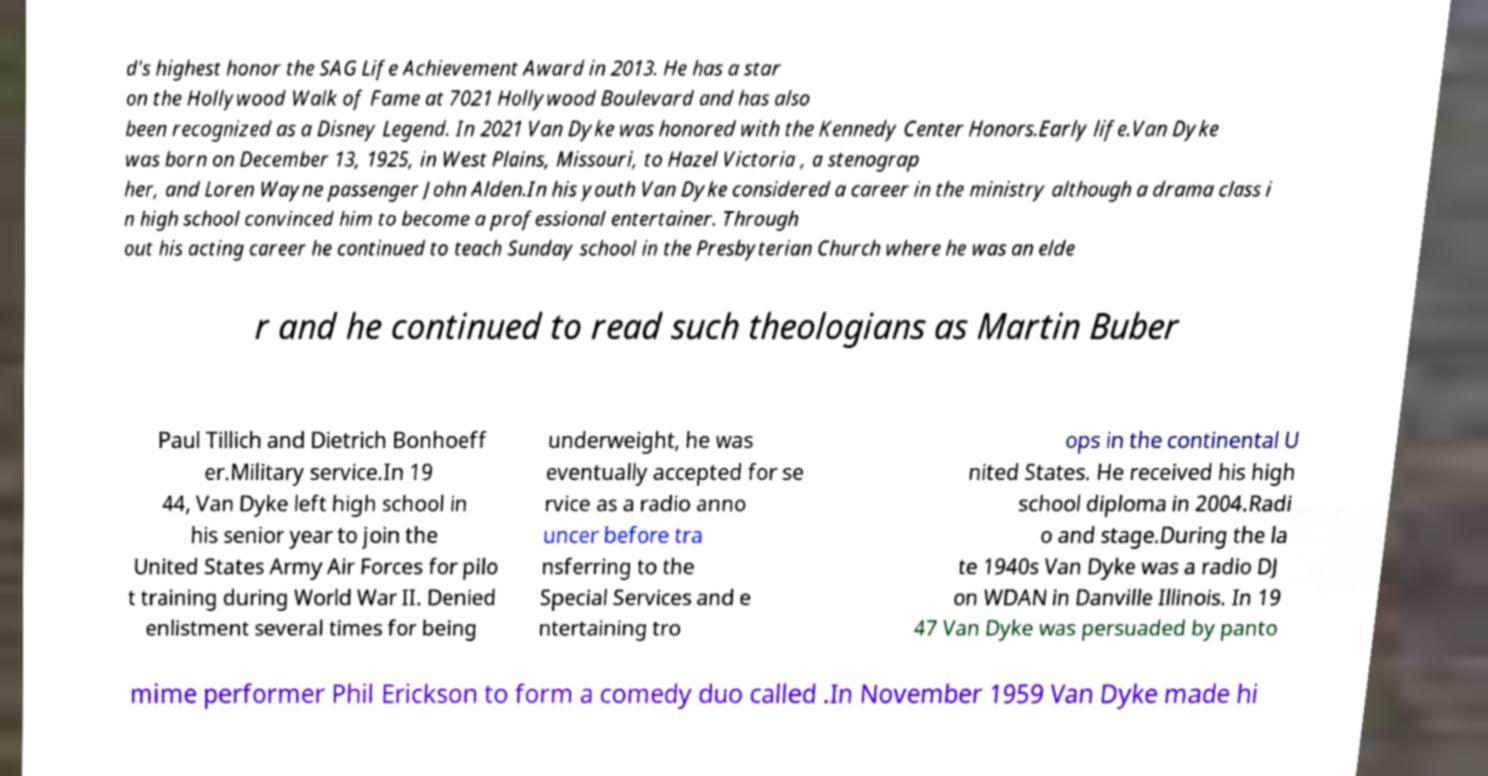There's text embedded in this image that I need extracted. Can you transcribe it verbatim? d's highest honor the SAG Life Achievement Award in 2013. He has a star on the Hollywood Walk of Fame at 7021 Hollywood Boulevard and has also been recognized as a Disney Legend. In 2021 Van Dyke was honored with the Kennedy Center Honors.Early life.Van Dyke was born on December 13, 1925, in West Plains, Missouri, to Hazel Victoria , a stenograp her, and Loren Wayne passenger John Alden.In his youth Van Dyke considered a career in the ministry although a drama class i n high school convinced him to become a professional entertainer. Through out his acting career he continued to teach Sunday school in the Presbyterian Church where he was an elde r and he continued to read such theologians as Martin Buber Paul Tillich and Dietrich Bonhoeff er.Military service.In 19 44, Van Dyke left high school in his senior year to join the United States Army Air Forces for pilo t training during World War II. Denied enlistment several times for being underweight, he was eventually accepted for se rvice as a radio anno uncer before tra nsferring to the Special Services and e ntertaining tro ops in the continental U nited States. He received his high school diploma in 2004.Radi o and stage.During the la te 1940s Van Dyke was a radio DJ on WDAN in Danville Illinois. In 19 47 Van Dyke was persuaded by panto mime performer Phil Erickson to form a comedy duo called .In November 1959 Van Dyke made hi 